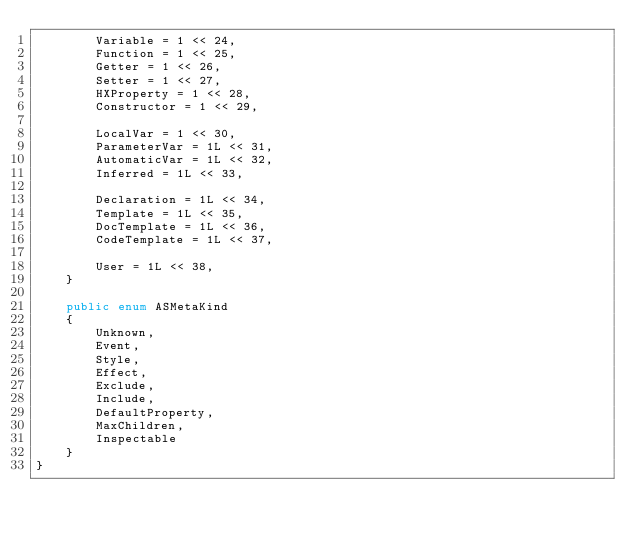Convert code to text. <code><loc_0><loc_0><loc_500><loc_500><_C#_>        Variable = 1 << 24,
        Function = 1 << 25,
        Getter = 1 << 26,
        Setter = 1 << 27,
        HXProperty = 1 << 28,
        Constructor = 1 << 29,

        LocalVar = 1 << 30,
        ParameterVar = 1L << 31,
        AutomaticVar = 1L << 32,
        Inferred = 1L << 33,

        Declaration = 1L << 34,
        Template = 1L << 35,
        DocTemplate = 1L << 36,
        CodeTemplate = 1L << 37,

        User = 1L << 38,
    }

    public enum ASMetaKind
    {
        Unknown,
        Event,
        Style,
        Effect,
        Exclude,
        Include,
        DefaultProperty,
        MaxChildren,
        Inspectable
    }
}</code> 